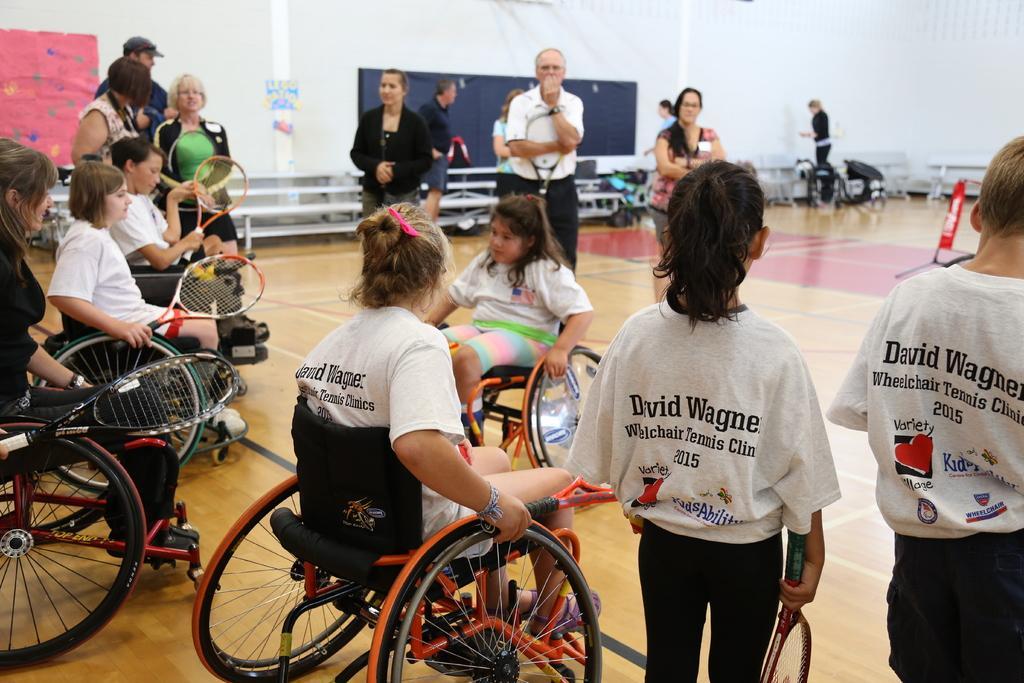Could you give a brief overview of what you see in this image? In this picture there are people those who are standing in the image and there are some girls those who are sitting on the wheel chairs and there are benches and posters in the image. 